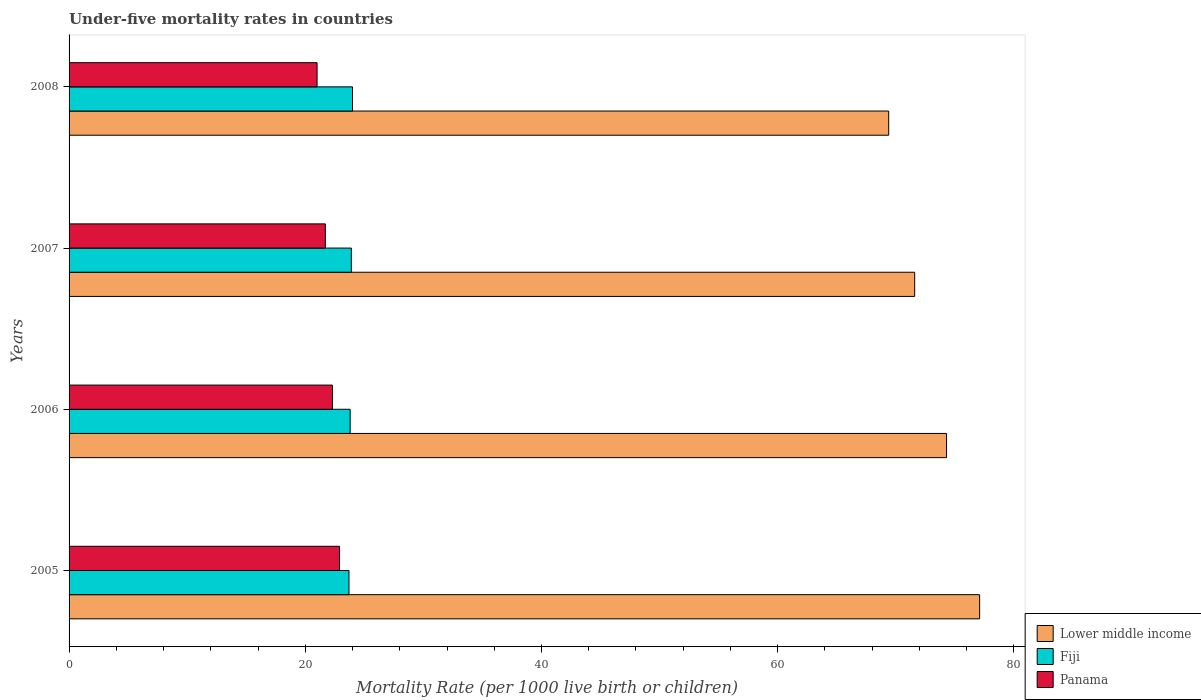How many different coloured bars are there?
Keep it short and to the point. 3. Are the number of bars per tick equal to the number of legend labels?
Your answer should be very brief. Yes. Are the number of bars on each tick of the Y-axis equal?
Keep it short and to the point. Yes. How many bars are there on the 1st tick from the bottom?
Ensure brevity in your answer.  3. What is the label of the 1st group of bars from the top?
Your answer should be very brief. 2008. What is the under-five mortality rate in Fiji in 2006?
Make the answer very short. 23.8. Across all years, what is the maximum under-five mortality rate in Lower middle income?
Provide a short and direct response. 77.1. Across all years, what is the minimum under-five mortality rate in Lower middle income?
Keep it short and to the point. 69.4. In which year was the under-five mortality rate in Fiji maximum?
Give a very brief answer. 2008. What is the total under-five mortality rate in Lower middle income in the graph?
Provide a short and direct response. 292.4. What is the difference between the under-five mortality rate in Lower middle income in 2006 and that in 2007?
Keep it short and to the point. 2.7. What is the difference between the under-five mortality rate in Fiji in 2006 and the under-five mortality rate in Panama in 2005?
Keep it short and to the point. 0.9. What is the average under-five mortality rate in Lower middle income per year?
Your response must be concise. 73.1. In the year 2008, what is the difference between the under-five mortality rate in Fiji and under-five mortality rate in Lower middle income?
Provide a short and direct response. -45.4. In how many years, is the under-five mortality rate in Lower middle income greater than 8 ?
Ensure brevity in your answer.  4. What is the ratio of the under-five mortality rate in Panama in 2005 to that in 2008?
Ensure brevity in your answer.  1.09. Is the under-five mortality rate in Lower middle income in 2006 less than that in 2007?
Give a very brief answer. No. What is the difference between the highest and the second highest under-five mortality rate in Lower middle income?
Offer a very short reply. 2.8. What is the difference between the highest and the lowest under-five mortality rate in Fiji?
Make the answer very short. 0.3. In how many years, is the under-five mortality rate in Panama greater than the average under-five mortality rate in Panama taken over all years?
Give a very brief answer. 2. Is the sum of the under-five mortality rate in Panama in 2005 and 2006 greater than the maximum under-five mortality rate in Lower middle income across all years?
Offer a very short reply. No. What does the 3rd bar from the top in 2006 represents?
Make the answer very short. Lower middle income. What does the 1st bar from the bottom in 2005 represents?
Offer a very short reply. Lower middle income. Is it the case that in every year, the sum of the under-five mortality rate in Lower middle income and under-five mortality rate in Panama is greater than the under-five mortality rate in Fiji?
Offer a very short reply. Yes. What is the difference between two consecutive major ticks on the X-axis?
Make the answer very short. 20. Are the values on the major ticks of X-axis written in scientific E-notation?
Your answer should be compact. No. Does the graph contain any zero values?
Your response must be concise. No. Does the graph contain grids?
Make the answer very short. No. Where does the legend appear in the graph?
Give a very brief answer. Bottom right. How many legend labels are there?
Give a very brief answer. 3. How are the legend labels stacked?
Offer a terse response. Vertical. What is the title of the graph?
Give a very brief answer. Under-five mortality rates in countries. What is the label or title of the X-axis?
Offer a terse response. Mortality Rate (per 1000 live birth or children). What is the Mortality Rate (per 1000 live birth or children) of Lower middle income in 2005?
Keep it short and to the point. 77.1. What is the Mortality Rate (per 1000 live birth or children) of Fiji in 2005?
Your answer should be very brief. 23.7. What is the Mortality Rate (per 1000 live birth or children) of Panama in 2005?
Make the answer very short. 22.9. What is the Mortality Rate (per 1000 live birth or children) of Lower middle income in 2006?
Give a very brief answer. 74.3. What is the Mortality Rate (per 1000 live birth or children) in Fiji in 2006?
Your answer should be very brief. 23.8. What is the Mortality Rate (per 1000 live birth or children) of Panama in 2006?
Your answer should be compact. 22.3. What is the Mortality Rate (per 1000 live birth or children) in Lower middle income in 2007?
Offer a very short reply. 71.6. What is the Mortality Rate (per 1000 live birth or children) in Fiji in 2007?
Offer a very short reply. 23.9. What is the Mortality Rate (per 1000 live birth or children) in Panama in 2007?
Offer a terse response. 21.7. What is the Mortality Rate (per 1000 live birth or children) of Lower middle income in 2008?
Provide a succinct answer. 69.4. Across all years, what is the maximum Mortality Rate (per 1000 live birth or children) in Lower middle income?
Your response must be concise. 77.1. Across all years, what is the maximum Mortality Rate (per 1000 live birth or children) of Fiji?
Provide a succinct answer. 24. Across all years, what is the maximum Mortality Rate (per 1000 live birth or children) of Panama?
Give a very brief answer. 22.9. Across all years, what is the minimum Mortality Rate (per 1000 live birth or children) in Lower middle income?
Offer a very short reply. 69.4. Across all years, what is the minimum Mortality Rate (per 1000 live birth or children) of Fiji?
Keep it short and to the point. 23.7. Across all years, what is the minimum Mortality Rate (per 1000 live birth or children) in Panama?
Your response must be concise. 21. What is the total Mortality Rate (per 1000 live birth or children) in Lower middle income in the graph?
Your answer should be very brief. 292.4. What is the total Mortality Rate (per 1000 live birth or children) in Fiji in the graph?
Offer a very short reply. 95.4. What is the total Mortality Rate (per 1000 live birth or children) in Panama in the graph?
Keep it short and to the point. 87.9. What is the difference between the Mortality Rate (per 1000 live birth or children) in Fiji in 2005 and that in 2006?
Your answer should be compact. -0.1. What is the difference between the Mortality Rate (per 1000 live birth or children) in Lower middle income in 2005 and that in 2007?
Make the answer very short. 5.5. What is the difference between the Mortality Rate (per 1000 live birth or children) in Fiji in 2005 and that in 2007?
Your response must be concise. -0.2. What is the difference between the Mortality Rate (per 1000 live birth or children) in Panama in 2005 and that in 2007?
Your answer should be compact. 1.2. What is the difference between the Mortality Rate (per 1000 live birth or children) in Lower middle income in 2005 and that in 2008?
Offer a very short reply. 7.7. What is the difference between the Mortality Rate (per 1000 live birth or children) of Fiji in 2006 and that in 2007?
Provide a succinct answer. -0.1. What is the difference between the Mortality Rate (per 1000 live birth or children) in Lower middle income in 2007 and that in 2008?
Ensure brevity in your answer.  2.2. What is the difference between the Mortality Rate (per 1000 live birth or children) of Panama in 2007 and that in 2008?
Offer a terse response. 0.7. What is the difference between the Mortality Rate (per 1000 live birth or children) of Lower middle income in 2005 and the Mortality Rate (per 1000 live birth or children) of Fiji in 2006?
Your answer should be compact. 53.3. What is the difference between the Mortality Rate (per 1000 live birth or children) in Lower middle income in 2005 and the Mortality Rate (per 1000 live birth or children) in Panama in 2006?
Your answer should be very brief. 54.8. What is the difference between the Mortality Rate (per 1000 live birth or children) of Lower middle income in 2005 and the Mortality Rate (per 1000 live birth or children) of Fiji in 2007?
Make the answer very short. 53.2. What is the difference between the Mortality Rate (per 1000 live birth or children) in Lower middle income in 2005 and the Mortality Rate (per 1000 live birth or children) in Panama in 2007?
Ensure brevity in your answer.  55.4. What is the difference between the Mortality Rate (per 1000 live birth or children) in Lower middle income in 2005 and the Mortality Rate (per 1000 live birth or children) in Fiji in 2008?
Keep it short and to the point. 53.1. What is the difference between the Mortality Rate (per 1000 live birth or children) of Lower middle income in 2005 and the Mortality Rate (per 1000 live birth or children) of Panama in 2008?
Keep it short and to the point. 56.1. What is the difference between the Mortality Rate (per 1000 live birth or children) of Fiji in 2005 and the Mortality Rate (per 1000 live birth or children) of Panama in 2008?
Your answer should be very brief. 2.7. What is the difference between the Mortality Rate (per 1000 live birth or children) in Lower middle income in 2006 and the Mortality Rate (per 1000 live birth or children) in Fiji in 2007?
Provide a succinct answer. 50.4. What is the difference between the Mortality Rate (per 1000 live birth or children) of Lower middle income in 2006 and the Mortality Rate (per 1000 live birth or children) of Panama in 2007?
Give a very brief answer. 52.6. What is the difference between the Mortality Rate (per 1000 live birth or children) of Lower middle income in 2006 and the Mortality Rate (per 1000 live birth or children) of Fiji in 2008?
Offer a very short reply. 50.3. What is the difference between the Mortality Rate (per 1000 live birth or children) of Lower middle income in 2006 and the Mortality Rate (per 1000 live birth or children) of Panama in 2008?
Offer a terse response. 53.3. What is the difference between the Mortality Rate (per 1000 live birth or children) in Lower middle income in 2007 and the Mortality Rate (per 1000 live birth or children) in Fiji in 2008?
Offer a terse response. 47.6. What is the difference between the Mortality Rate (per 1000 live birth or children) in Lower middle income in 2007 and the Mortality Rate (per 1000 live birth or children) in Panama in 2008?
Your answer should be compact. 50.6. What is the difference between the Mortality Rate (per 1000 live birth or children) in Fiji in 2007 and the Mortality Rate (per 1000 live birth or children) in Panama in 2008?
Offer a terse response. 2.9. What is the average Mortality Rate (per 1000 live birth or children) in Lower middle income per year?
Offer a very short reply. 73.1. What is the average Mortality Rate (per 1000 live birth or children) in Fiji per year?
Keep it short and to the point. 23.85. What is the average Mortality Rate (per 1000 live birth or children) in Panama per year?
Give a very brief answer. 21.98. In the year 2005, what is the difference between the Mortality Rate (per 1000 live birth or children) of Lower middle income and Mortality Rate (per 1000 live birth or children) of Fiji?
Offer a terse response. 53.4. In the year 2005, what is the difference between the Mortality Rate (per 1000 live birth or children) of Lower middle income and Mortality Rate (per 1000 live birth or children) of Panama?
Offer a very short reply. 54.2. In the year 2006, what is the difference between the Mortality Rate (per 1000 live birth or children) of Lower middle income and Mortality Rate (per 1000 live birth or children) of Fiji?
Offer a terse response. 50.5. In the year 2007, what is the difference between the Mortality Rate (per 1000 live birth or children) in Lower middle income and Mortality Rate (per 1000 live birth or children) in Fiji?
Provide a succinct answer. 47.7. In the year 2007, what is the difference between the Mortality Rate (per 1000 live birth or children) of Lower middle income and Mortality Rate (per 1000 live birth or children) of Panama?
Provide a short and direct response. 49.9. In the year 2007, what is the difference between the Mortality Rate (per 1000 live birth or children) of Fiji and Mortality Rate (per 1000 live birth or children) of Panama?
Ensure brevity in your answer.  2.2. In the year 2008, what is the difference between the Mortality Rate (per 1000 live birth or children) of Lower middle income and Mortality Rate (per 1000 live birth or children) of Fiji?
Provide a succinct answer. 45.4. In the year 2008, what is the difference between the Mortality Rate (per 1000 live birth or children) in Lower middle income and Mortality Rate (per 1000 live birth or children) in Panama?
Ensure brevity in your answer.  48.4. In the year 2008, what is the difference between the Mortality Rate (per 1000 live birth or children) of Fiji and Mortality Rate (per 1000 live birth or children) of Panama?
Provide a succinct answer. 3. What is the ratio of the Mortality Rate (per 1000 live birth or children) in Lower middle income in 2005 to that in 2006?
Your response must be concise. 1.04. What is the ratio of the Mortality Rate (per 1000 live birth or children) in Panama in 2005 to that in 2006?
Provide a short and direct response. 1.03. What is the ratio of the Mortality Rate (per 1000 live birth or children) of Lower middle income in 2005 to that in 2007?
Offer a terse response. 1.08. What is the ratio of the Mortality Rate (per 1000 live birth or children) in Panama in 2005 to that in 2007?
Offer a terse response. 1.06. What is the ratio of the Mortality Rate (per 1000 live birth or children) in Lower middle income in 2005 to that in 2008?
Make the answer very short. 1.11. What is the ratio of the Mortality Rate (per 1000 live birth or children) of Fiji in 2005 to that in 2008?
Offer a very short reply. 0.99. What is the ratio of the Mortality Rate (per 1000 live birth or children) of Panama in 2005 to that in 2008?
Provide a succinct answer. 1.09. What is the ratio of the Mortality Rate (per 1000 live birth or children) in Lower middle income in 2006 to that in 2007?
Ensure brevity in your answer.  1.04. What is the ratio of the Mortality Rate (per 1000 live birth or children) of Fiji in 2006 to that in 2007?
Give a very brief answer. 1. What is the ratio of the Mortality Rate (per 1000 live birth or children) of Panama in 2006 to that in 2007?
Offer a very short reply. 1.03. What is the ratio of the Mortality Rate (per 1000 live birth or children) in Lower middle income in 2006 to that in 2008?
Give a very brief answer. 1.07. What is the ratio of the Mortality Rate (per 1000 live birth or children) of Fiji in 2006 to that in 2008?
Your answer should be very brief. 0.99. What is the ratio of the Mortality Rate (per 1000 live birth or children) in Panama in 2006 to that in 2008?
Make the answer very short. 1.06. What is the ratio of the Mortality Rate (per 1000 live birth or children) of Lower middle income in 2007 to that in 2008?
Provide a succinct answer. 1.03. What is the ratio of the Mortality Rate (per 1000 live birth or children) in Fiji in 2007 to that in 2008?
Offer a terse response. 1. What is the ratio of the Mortality Rate (per 1000 live birth or children) in Panama in 2007 to that in 2008?
Offer a terse response. 1.03. What is the difference between the highest and the second highest Mortality Rate (per 1000 live birth or children) of Lower middle income?
Ensure brevity in your answer.  2.8. What is the difference between the highest and the second highest Mortality Rate (per 1000 live birth or children) in Panama?
Provide a short and direct response. 0.6. What is the difference between the highest and the lowest Mortality Rate (per 1000 live birth or children) in Lower middle income?
Make the answer very short. 7.7. What is the difference between the highest and the lowest Mortality Rate (per 1000 live birth or children) in Fiji?
Keep it short and to the point. 0.3. 